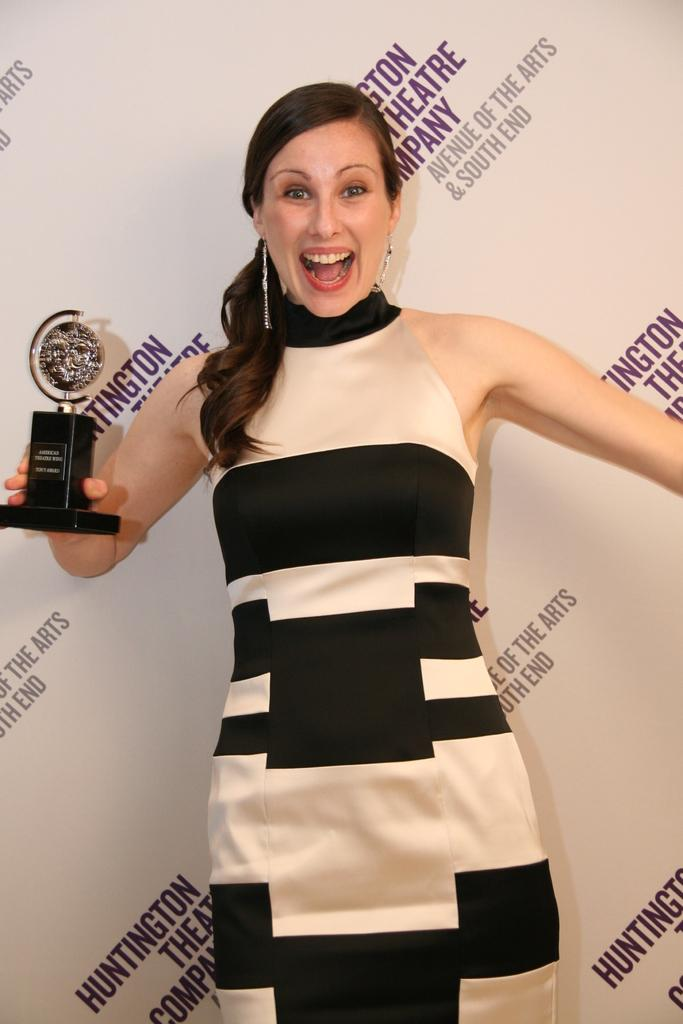<image>
Give a short and clear explanation of the subsequent image. A woman is holding a trophy in front of a wall with the word theatre printed on it. 